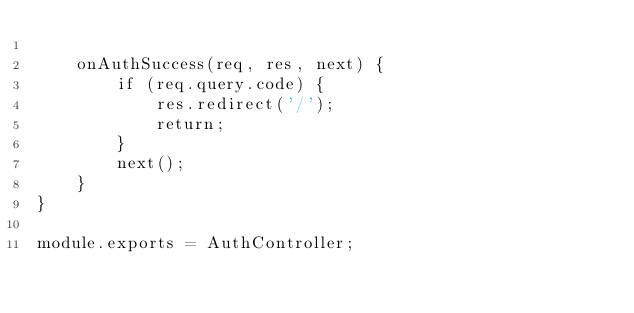<code> <loc_0><loc_0><loc_500><loc_500><_JavaScript_>
    onAuthSuccess(req, res, next) {
        if (req.query.code) {
            res.redirect('/');
            return;
        }
        next();
    }
}

module.exports = AuthController;
</code> 